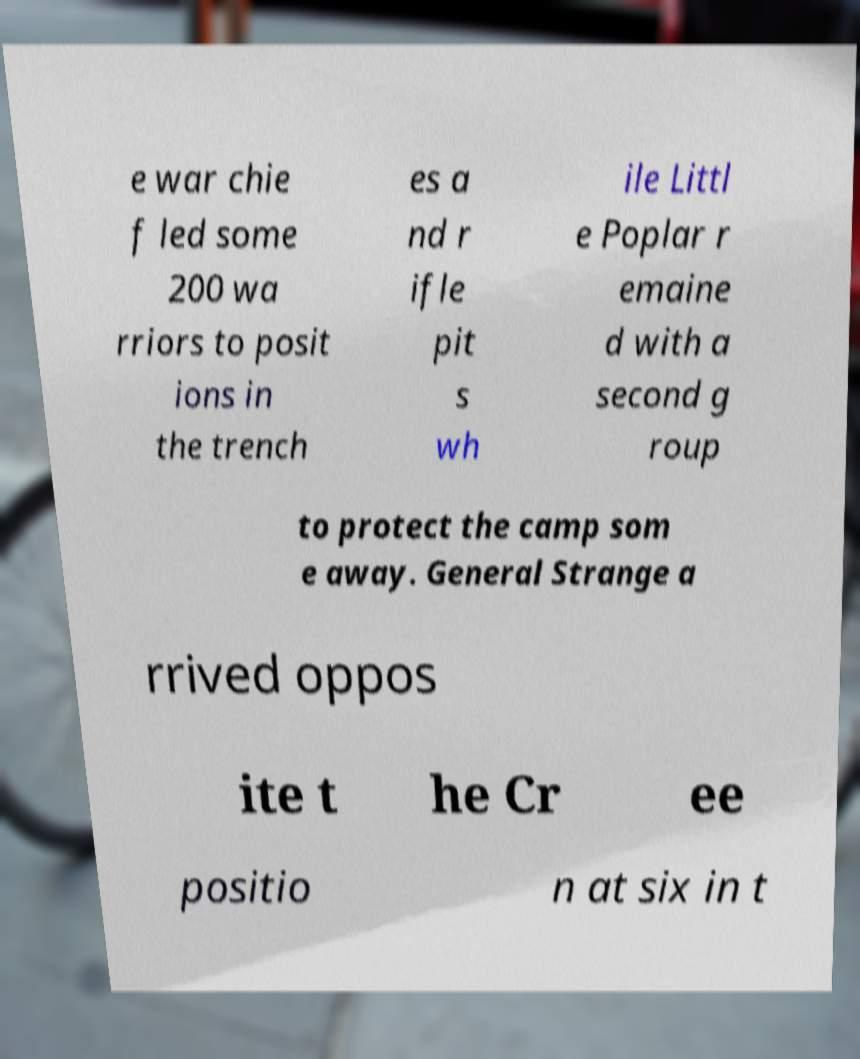Could you assist in decoding the text presented in this image and type it out clearly? e war chie f led some 200 wa rriors to posit ions in the trench es a nd r ifle pit s wh ile Littl e Poplar r emaine d with a second g roup to protect the camp som e away. General Strange a rrived oppos ite t he Cr ee positio n at six in t 